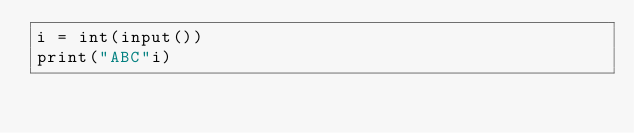Convert code to text. <code><loc_0><loc_0><loc_500><loc_500><_Python_>i = int(input())
print("ABC"i)</code> 